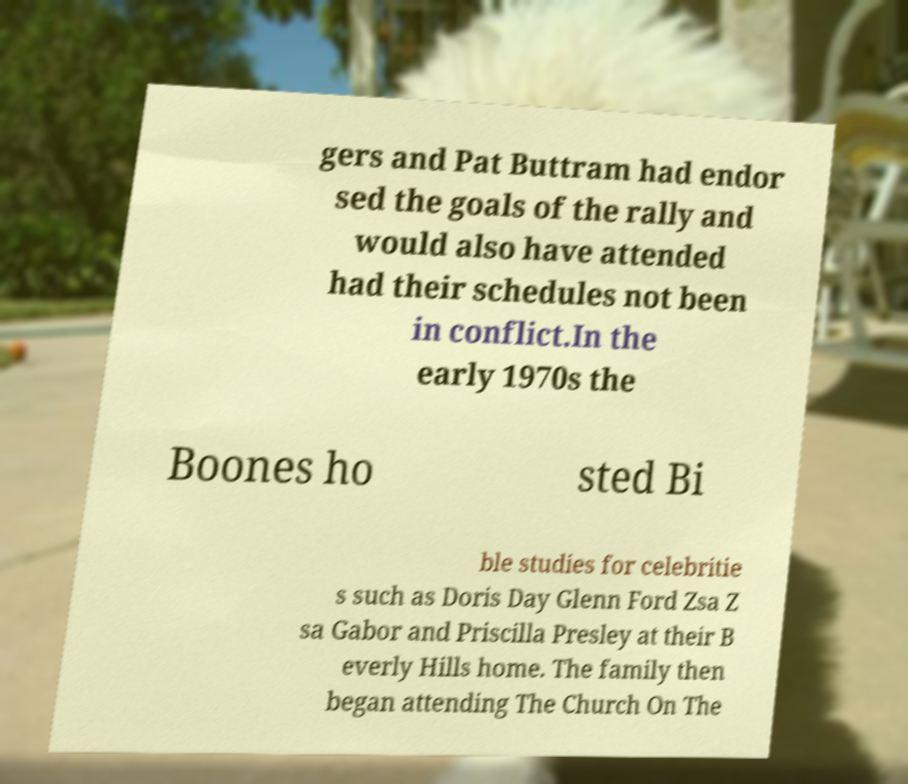Could you extract and type out the text from this image? gers and Pat Buttram had endor sed the goals of the rally and would also have attended had their schedules not been in conflict.In the early 1970s the Boones ho sted Bi ble studies for celebritie s such as Doris Day Glenn Ford Zsa Z sa Gabor and Priscilla Presley at their B everly Hills home. The family then began attending The Church On The 